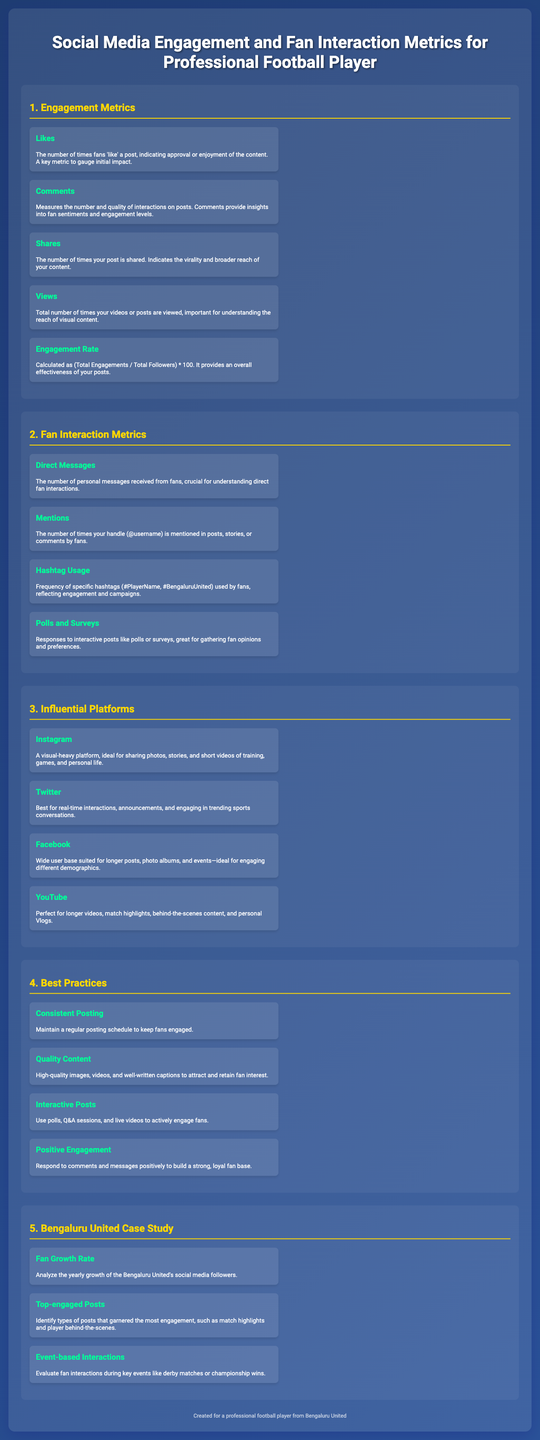What are the Engagement Metrics? The section lists various metrics that pertain to fan engagements, such as likes, comments, shares, views, and engagement rate.
Answer: Likes, Comments, Shares, Views, Engagement Rate What does the Engagement Rate measure? It is calculated as (Total Engagements / Total Followers) * 100, indicating overall effectiveness of posts.
Answer: Overall effectiveness of posts Which platform is best for real-time interactions? The document categorizes different platforms and identifies Twitter as the best for real-time interactions.
Answer: Twitter What type of posts garnered the most engagement according to the Bengaluru United case study? This section indicates that match highlights and player behind-the-scenes content received high engagement.
Answer: Match highlights and player behind-the-scenes What is suggested for maintaining fan interest? The document emphasizes the importance of maintaining a regular posting schedule as a best practice.
Answer: Consistent Posting How is Hashtag Usage defined in the document? It pertains to the frequency of specific hashtags used by fans, indicating engagement levels.
Answer: Frequency of specific hashtags 